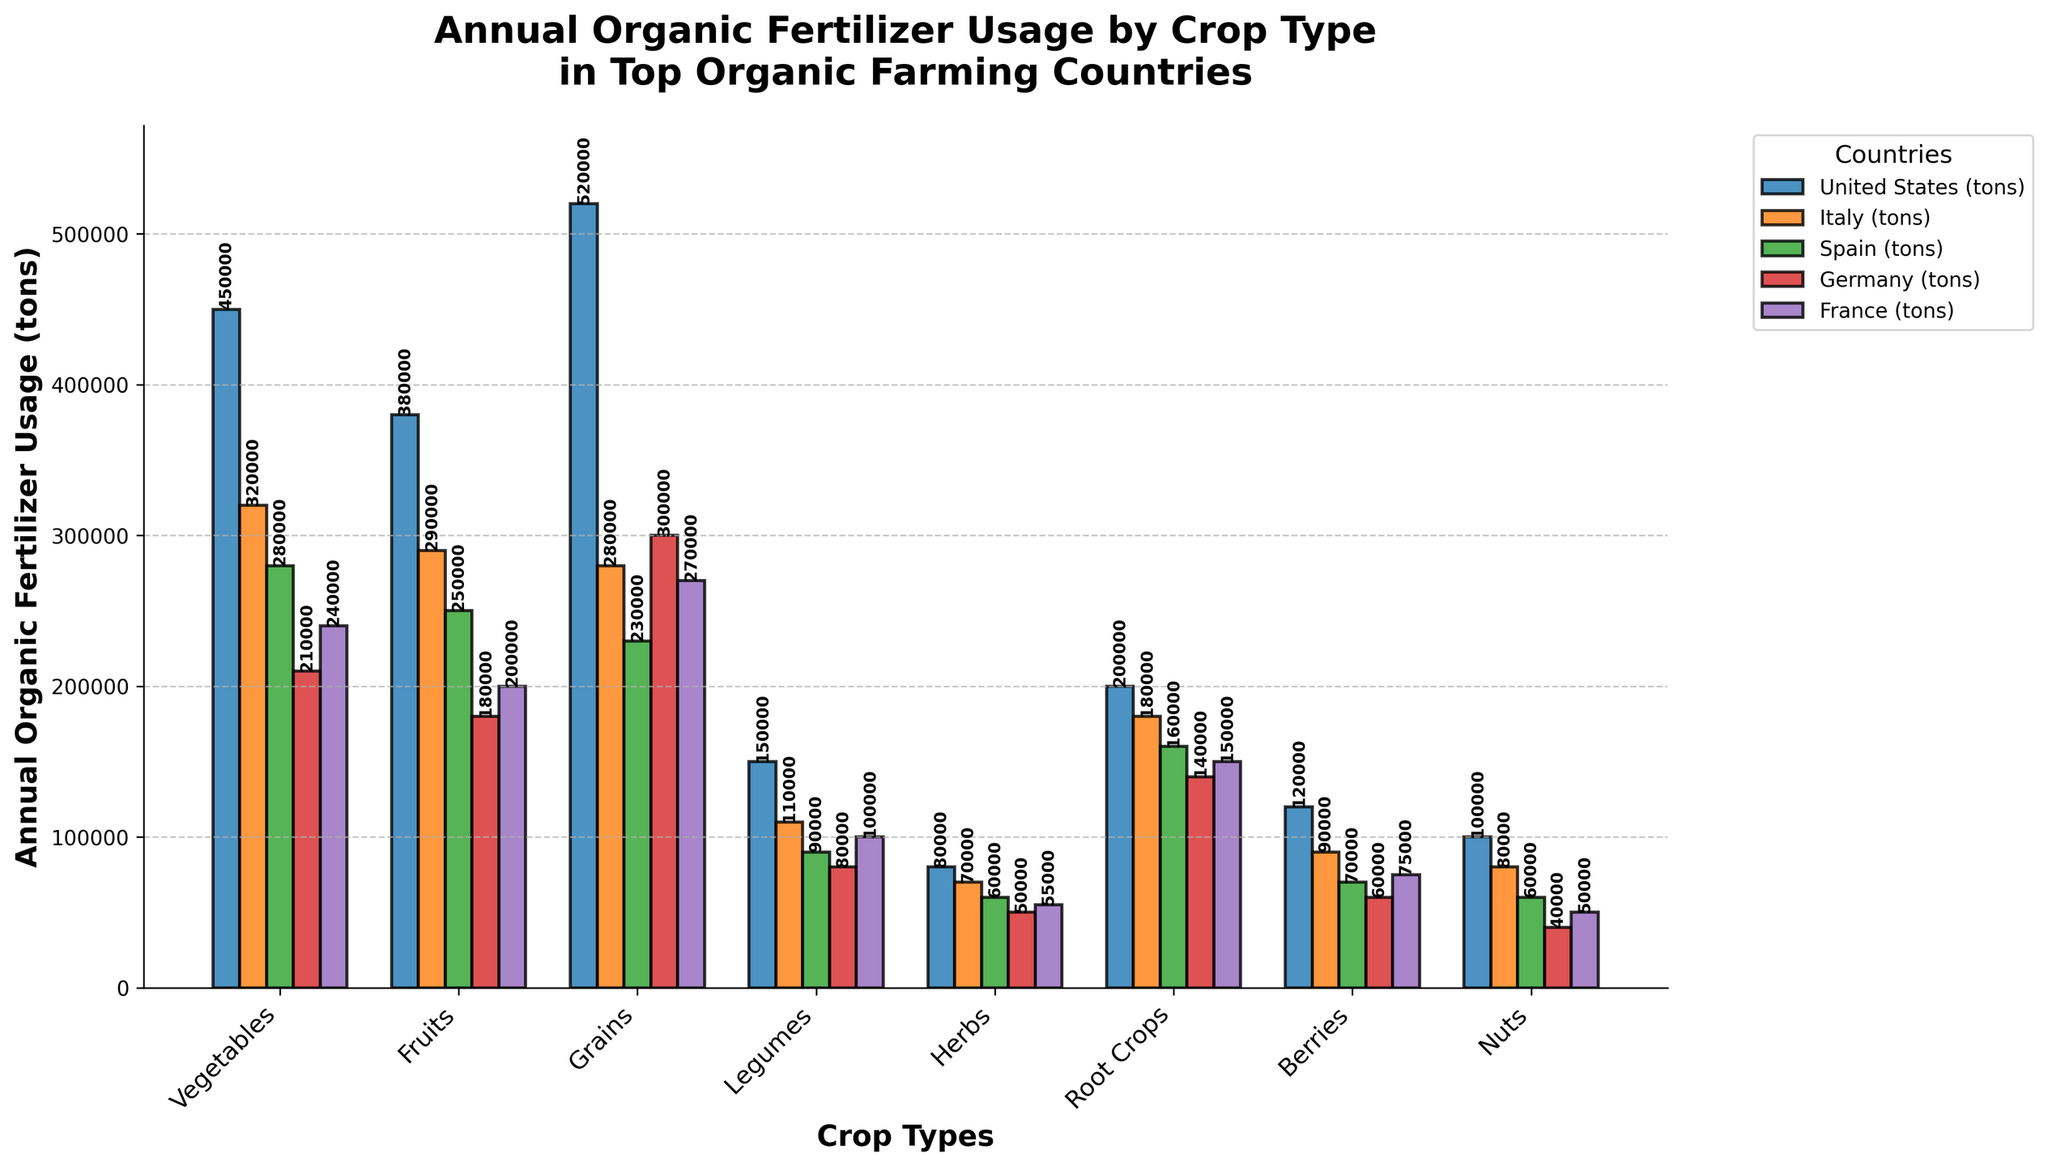Which country uses the most organic fertilizer for grains? To find the country that uses the most organic fertilizer for grains, locate the bar corresponding to "Grains" and compare their heights. The tallest bar represents the country with the highest usage.
Answer: United States Which crop type has the highest organic fertilizer usage in Italy? To determine the crop type with the highest organic fertilizer usage in Italy, compare the heights of the bars representing Italy. The highest bar corresponds to the crop type with the highest usage.
Answer: Vegetables How much more organic fertilizer does Germany use for fruits compared to legumes? Look at the bars for fruits and legumes for Germany, note their values, then subtract the value for legumes from the value for fruits (180000 - 80000).
Answer: 100000 What is the average annual organic fertilizer usage for vegetables across all countries? Add the values for vegetables across all countries (450000 + 320000 + 280000 + 210000 + 240000), then divide by the number of countries (5).
Answer: 300000 Which country has the smallest difference in organic fertilizer usage between vegetables and fruits? Calculate the absolute difference in usage between vegetables and fruits for each country, then identify the smallest difference: United States (70000), Italy (30000), Spain (30000), Germany (30000), France (40000). The smallest difference is 30000.
Answer: Italy, Spain, or Germany Which crop type has the least overall usage of organic fertilizer in the United States? Examine the bar representing the United States across all crop types and identify the lowest one.
Answer: Herbs Is the usage of organic fertilizer for berries in Spain greater, lesser, or equal to that in France? Compare the height of the berry bars for Spain and France. Spain's bar is at 70000, France's bar is at 75000.
Answer: Lesser By how much does the organic fertilizer usage for legumes in Italy exceed that for herbs in Spain? Find the values for legumes in Italy (110000) and herbs in Spain (60000), then subtract the latter from the former (110000 - 60000).
Answer: 50000 What is the total annual organic fertilizer usage for root crops across all countries? Sum the values for root crops for all countries (200000 + 180000 + 160000 + 140000 + 150000).
Answer: 830000 Are legumes one of the top three crop types in terms of organic fertilizer usage in the United States? List the crop types in the United States by descending order of usage and see if legumes fall within the top three. The order is: Grains (520000), Vegetables (450000), Fruits (380000), Legumes (150000).
Answer: No 